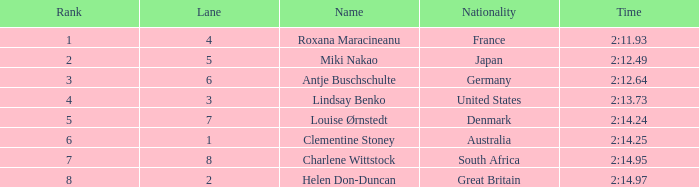What shows for nationality when there is a rank larger than 6, and a Time of 2:14.95? South Africa. 